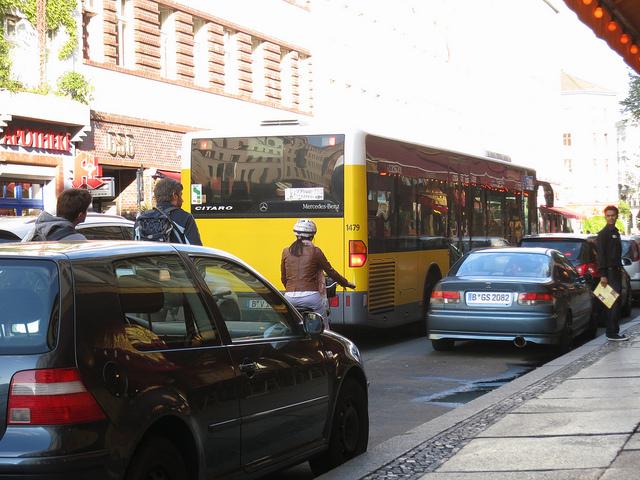Describe the overall atmosphere of the place shown in the image. The setting appears to be an urban street during daylight hours with bright sunshine casting shadows on the ground. It seems to be a busy area, possibly during a weekday, as evidenced by the people commuting on bikes and the presence of public transport. The architecture hints at a European city vibe, with older buildings and a well-organized transportation system. 